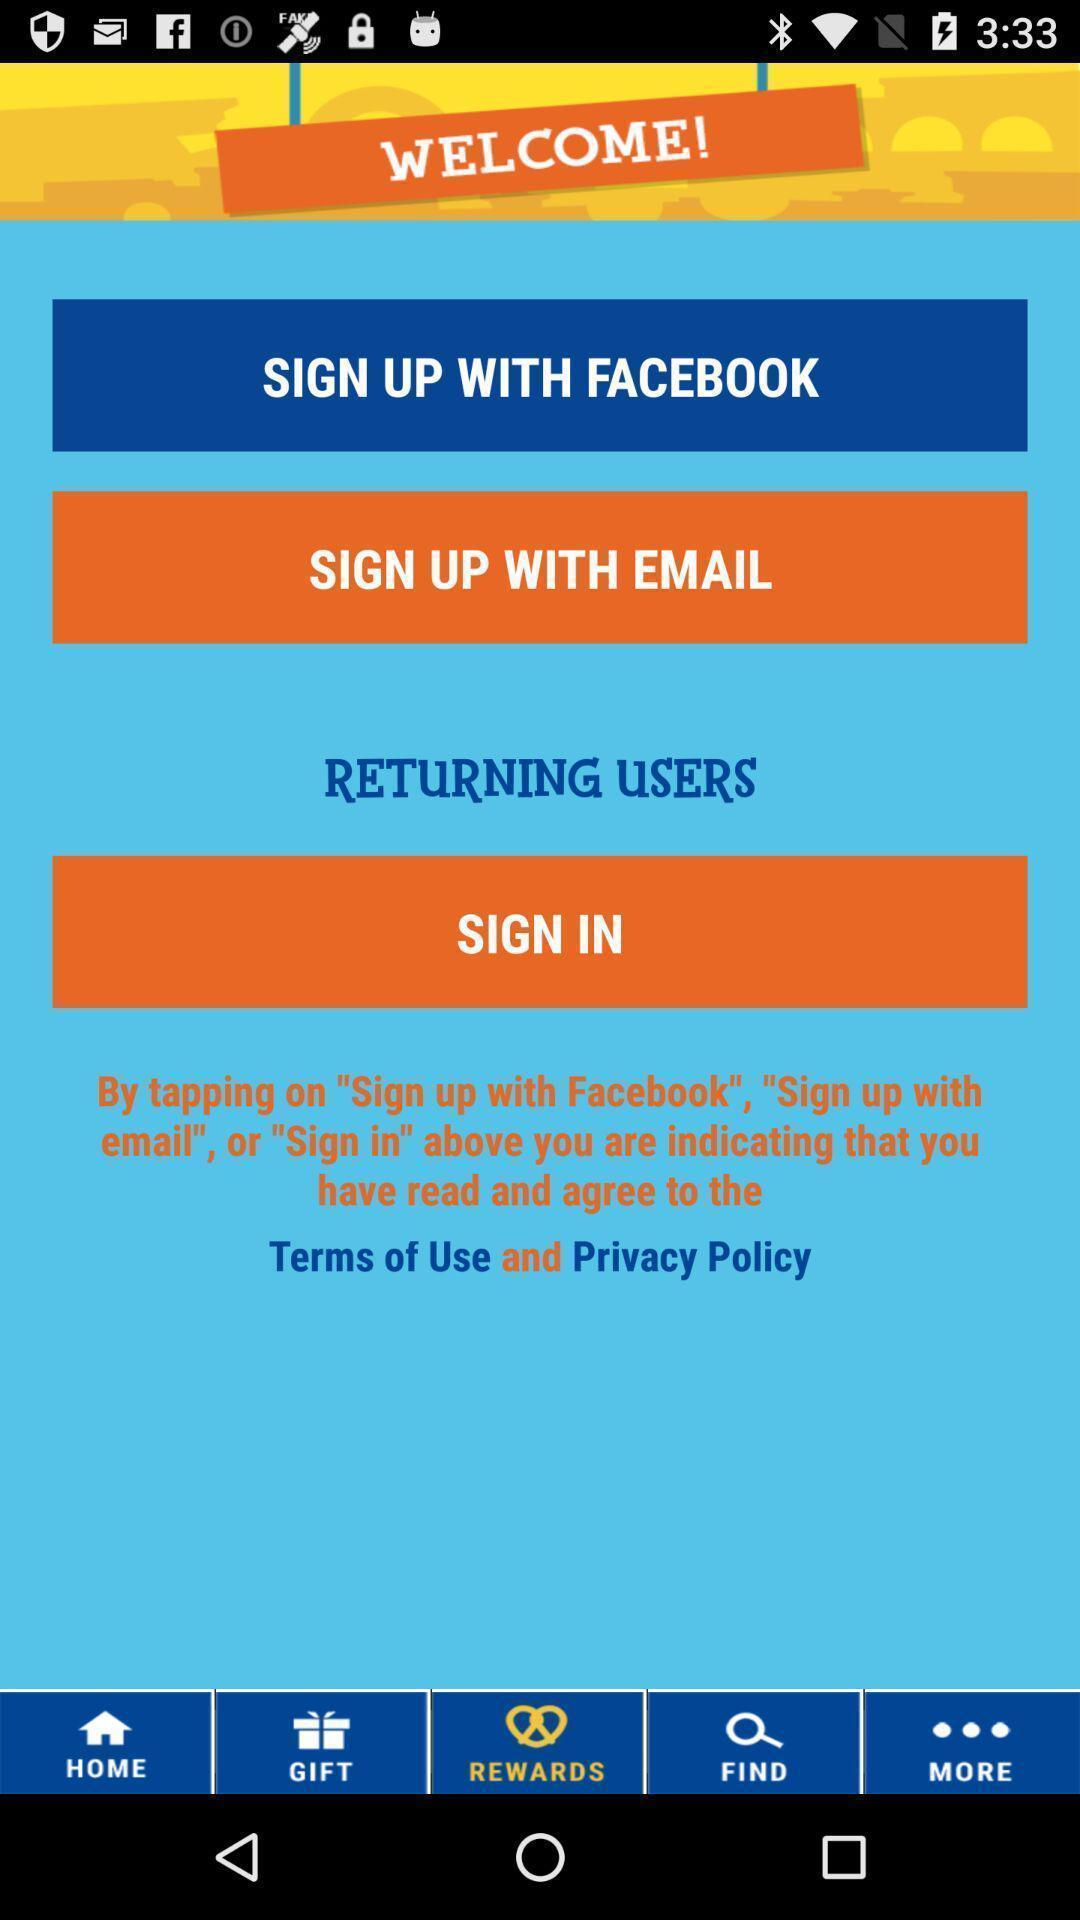Provide a textual representation of this image. Welcome to the sign in page. 